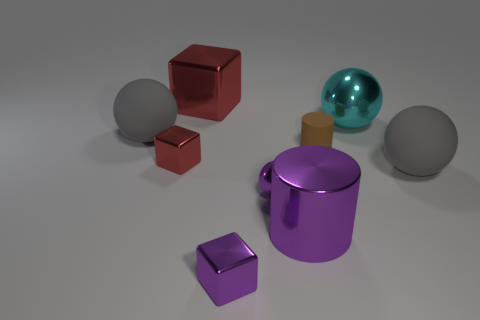There is a large sphere that is made of the same material as the purple cylinder; what is its color?
Provide a short and direct response. Cyan. Are there fewer cyan shiny things than large brown cylinders?
Provide a short and direct response. No. There is a red object that is in front of the big red shiny thing; does it have the same shape as the large gray thing that is to the right of the big purple shiny object?
Offer a terse response. No. How many objects are either tiny red spheres or tiny red metallic things?
Make the answer very short. 1. The metallic ball that is the same size as the matte cylinder is what color?
Offer a terse response. Purple. There is a large matte thing that is in front of the small matte cylinder; what number of big matte spheres are to the left of it?
Your answer should be compact. 1. What number of large spheres are both behind the tiny brown rubber object and on the right side of the big red cube?
Your answer should be very brief. 1. How many objects are spheres on the right side of the big purple thing or purple metal spheres behind the big purple object?
Provide a short and direct response. 3. How many other things are there of the same size as the purple metallic sphere?
Offer a very short reply. 3. What shape is the big metallic thing that is in front of the gray matte thing on the left side of the purple cube?
Offer a very short reply. Cylinder. 